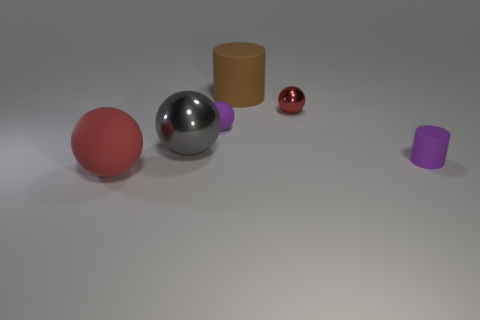What number of objects are the same material as the purple cylinder? There are three objects that appear to be made of the same material as the purple cylinder, which suggests they have a matte surface similar to the purple cylinder's texture. 